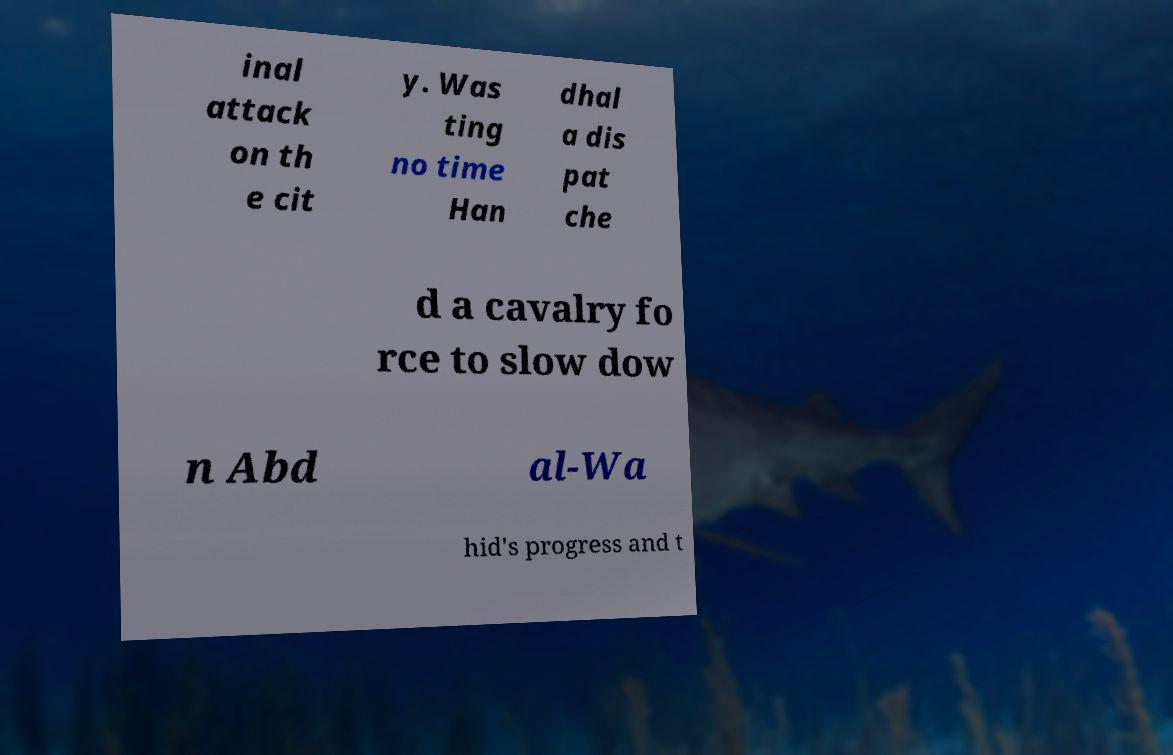Could you assist in decoding the text presented in this image and type it out clearly? inal attack on th e cit y. Was ting no time Han dhal a dis pat che d a cavalry fo rce to slow dow n Abd al-Wa hid's progress and t 